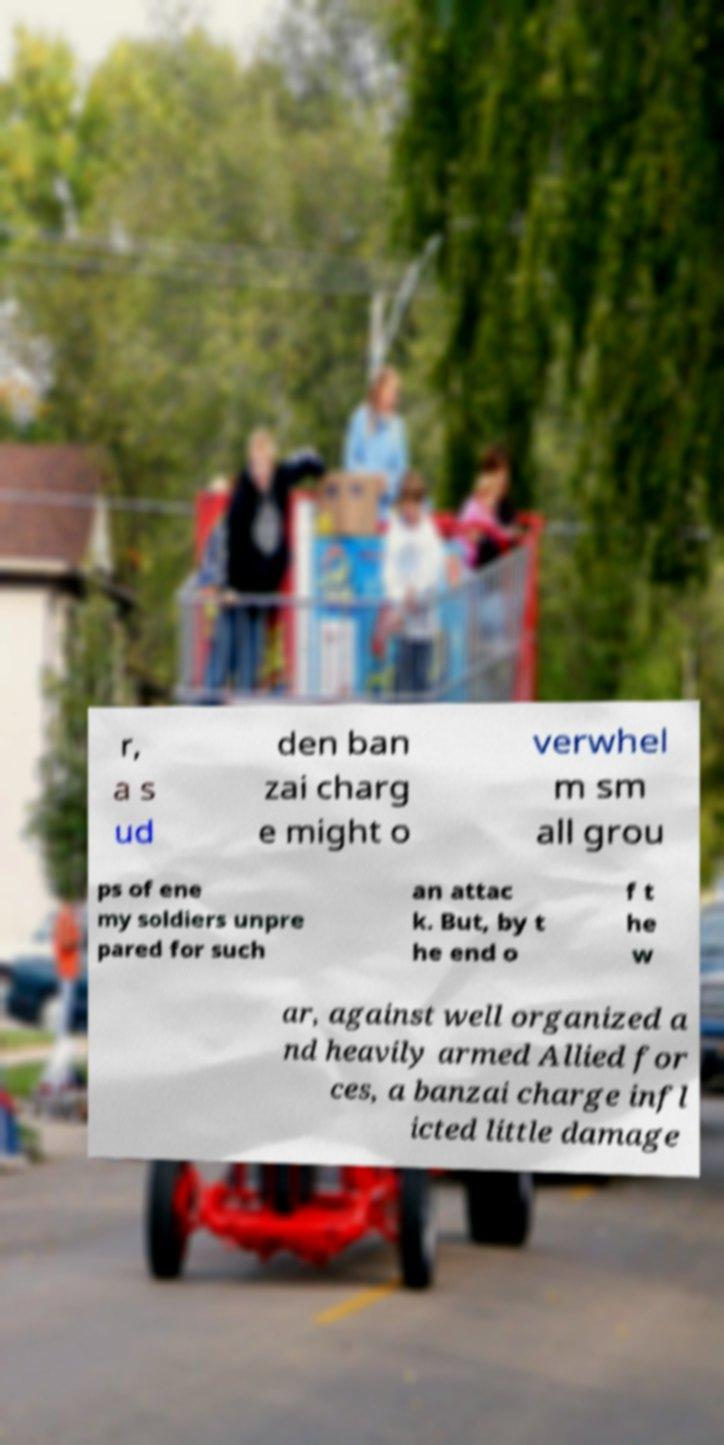Can you read and provide the text displayed in the image?This photo seems to have some interesting text. Can you extract and type it out for me? r, a s ud den ban zai charg e might o verwhel m sm all grou ps of ene my soldiers unpre pared for such an attac k. But, by t he end o f t he w ar, against well organized a nd heavily armed Allied for ces, a banzai charge infl icted little damage 